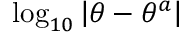<formula> <loc_0><loc_0><loc_500><loc_500>\log _ { 1 0 } \left | \theta - \theta ^ { a } \right |</formula> 